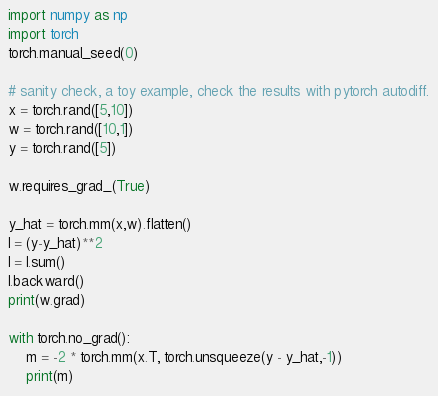<code> <loc_0><loc_0><loc_500><loc_500><_Python_>import numpy as np
import torch
torch.manual_seed(0)

# sanity check, a toy example, check the results with pytorch autodiff.
x = torch.rand([5,10])
w = torch.rand([10,1])
y = torch.rand([5])

w.requires_grad_(True)

y_hat = torch.mm(x,w).flatten()
l = (y-y_hat)**2
l = l.sum()
l.backward()
print(w.grad)

with torch.no_grad():
    m = -2 * torch.mm(x.T, torch.unsqueeze(y - y_hat,-1))
    print(m)
</code> 